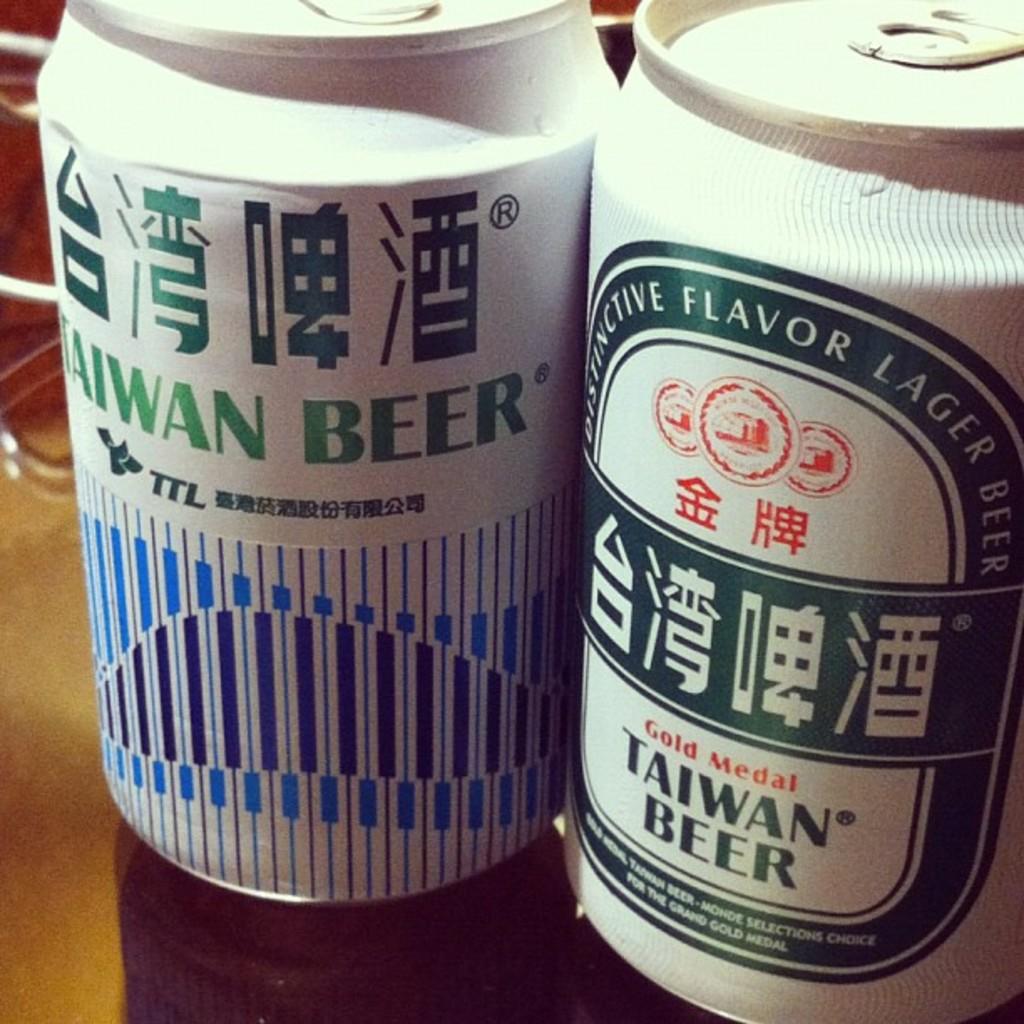What country is this beer affiliated with?
Make the answer very short. Taiwan. What brand of beer is this?
Your answer should be compact. Taiwan beer. 